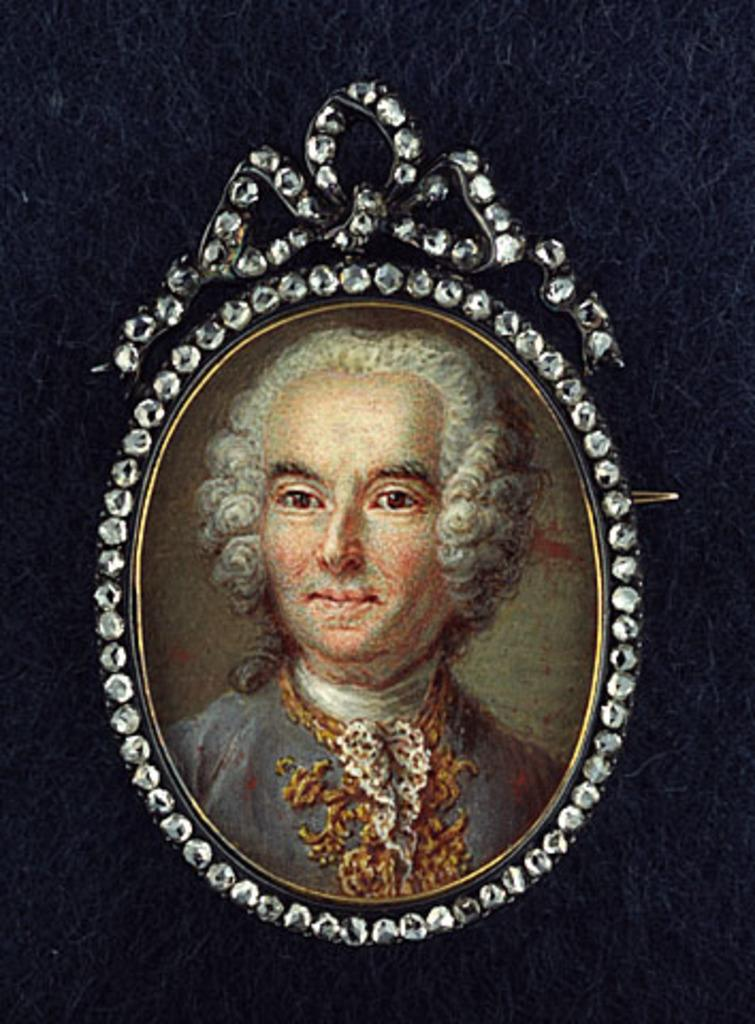What object is present in the image that typically holds a picture? There is a photo frame in the image. What is displayed in the photo frame? The photo frame contains a picture of a person. How is the photo frame positioned in the image? The photo frame is attached to the wall. What type of pickle is shown in the picture inside the photo frame? There is no pickle present in the image; the photo frame contains a picture of a person. Can you hear the horn in the image? There is no horn present in the image; it only contains a photo frame with a picture of a person. 